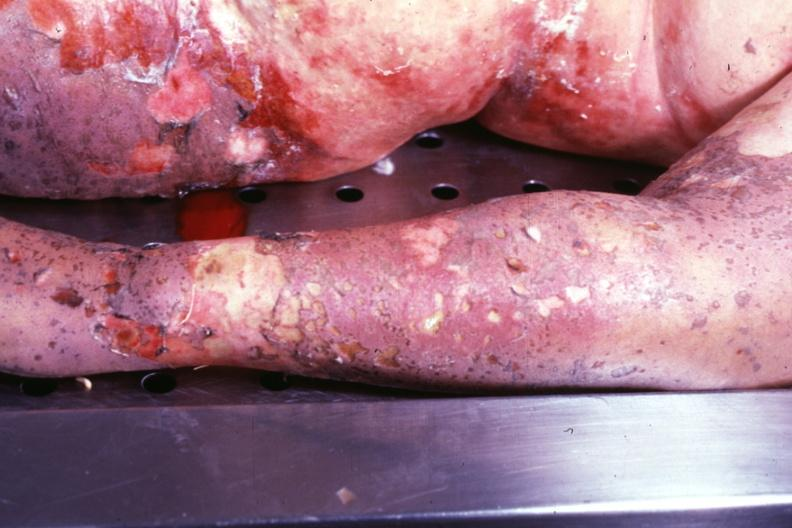s toxic epidermal necrolysis present?
Answer the question using a single word or phrase. Yes 